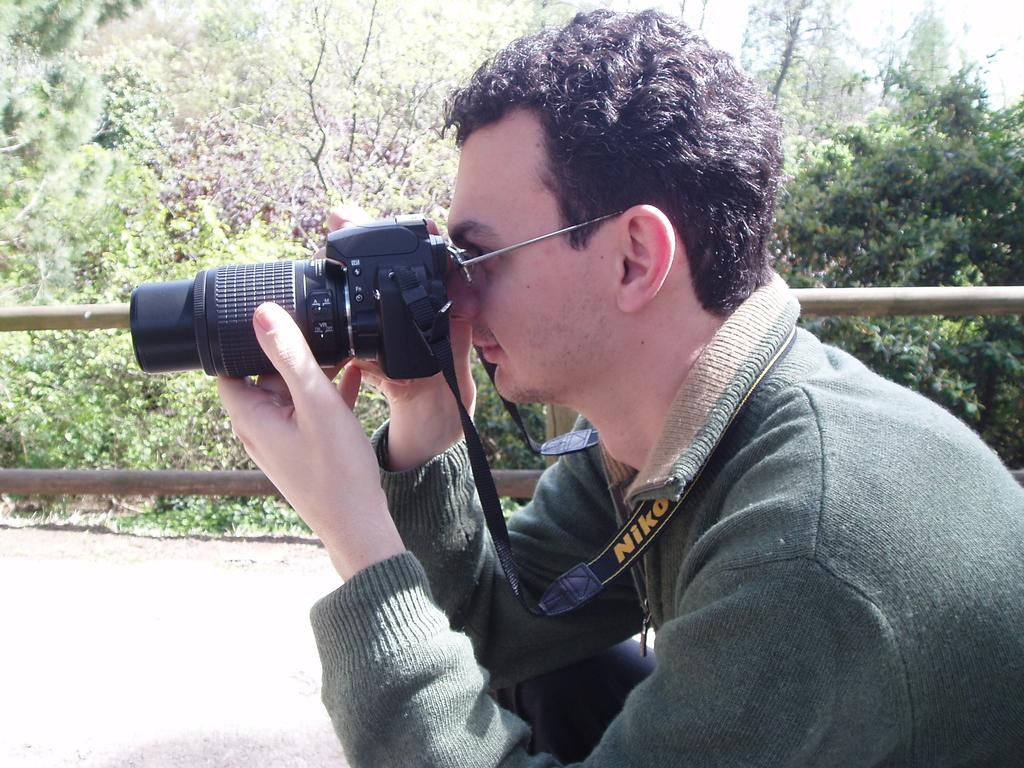What is the main subject of the picture? The main subject of the picture is a man. What is the man wearing in the image? The man is wearing spectacles in the image. What is the man holding in the picture? The man is holding a camera in the picture. What is the man doing with the camera? The man is taking a picture with the camera. What can be seen in the background of the image? There are trees and a wooden fence in the background of the image. What type of copper material can be seen on the page in the image? There is no copper material or page present in the image. What activity is the man participating in with the copper material in the image? There is no copper material or activity involving it in the image. 